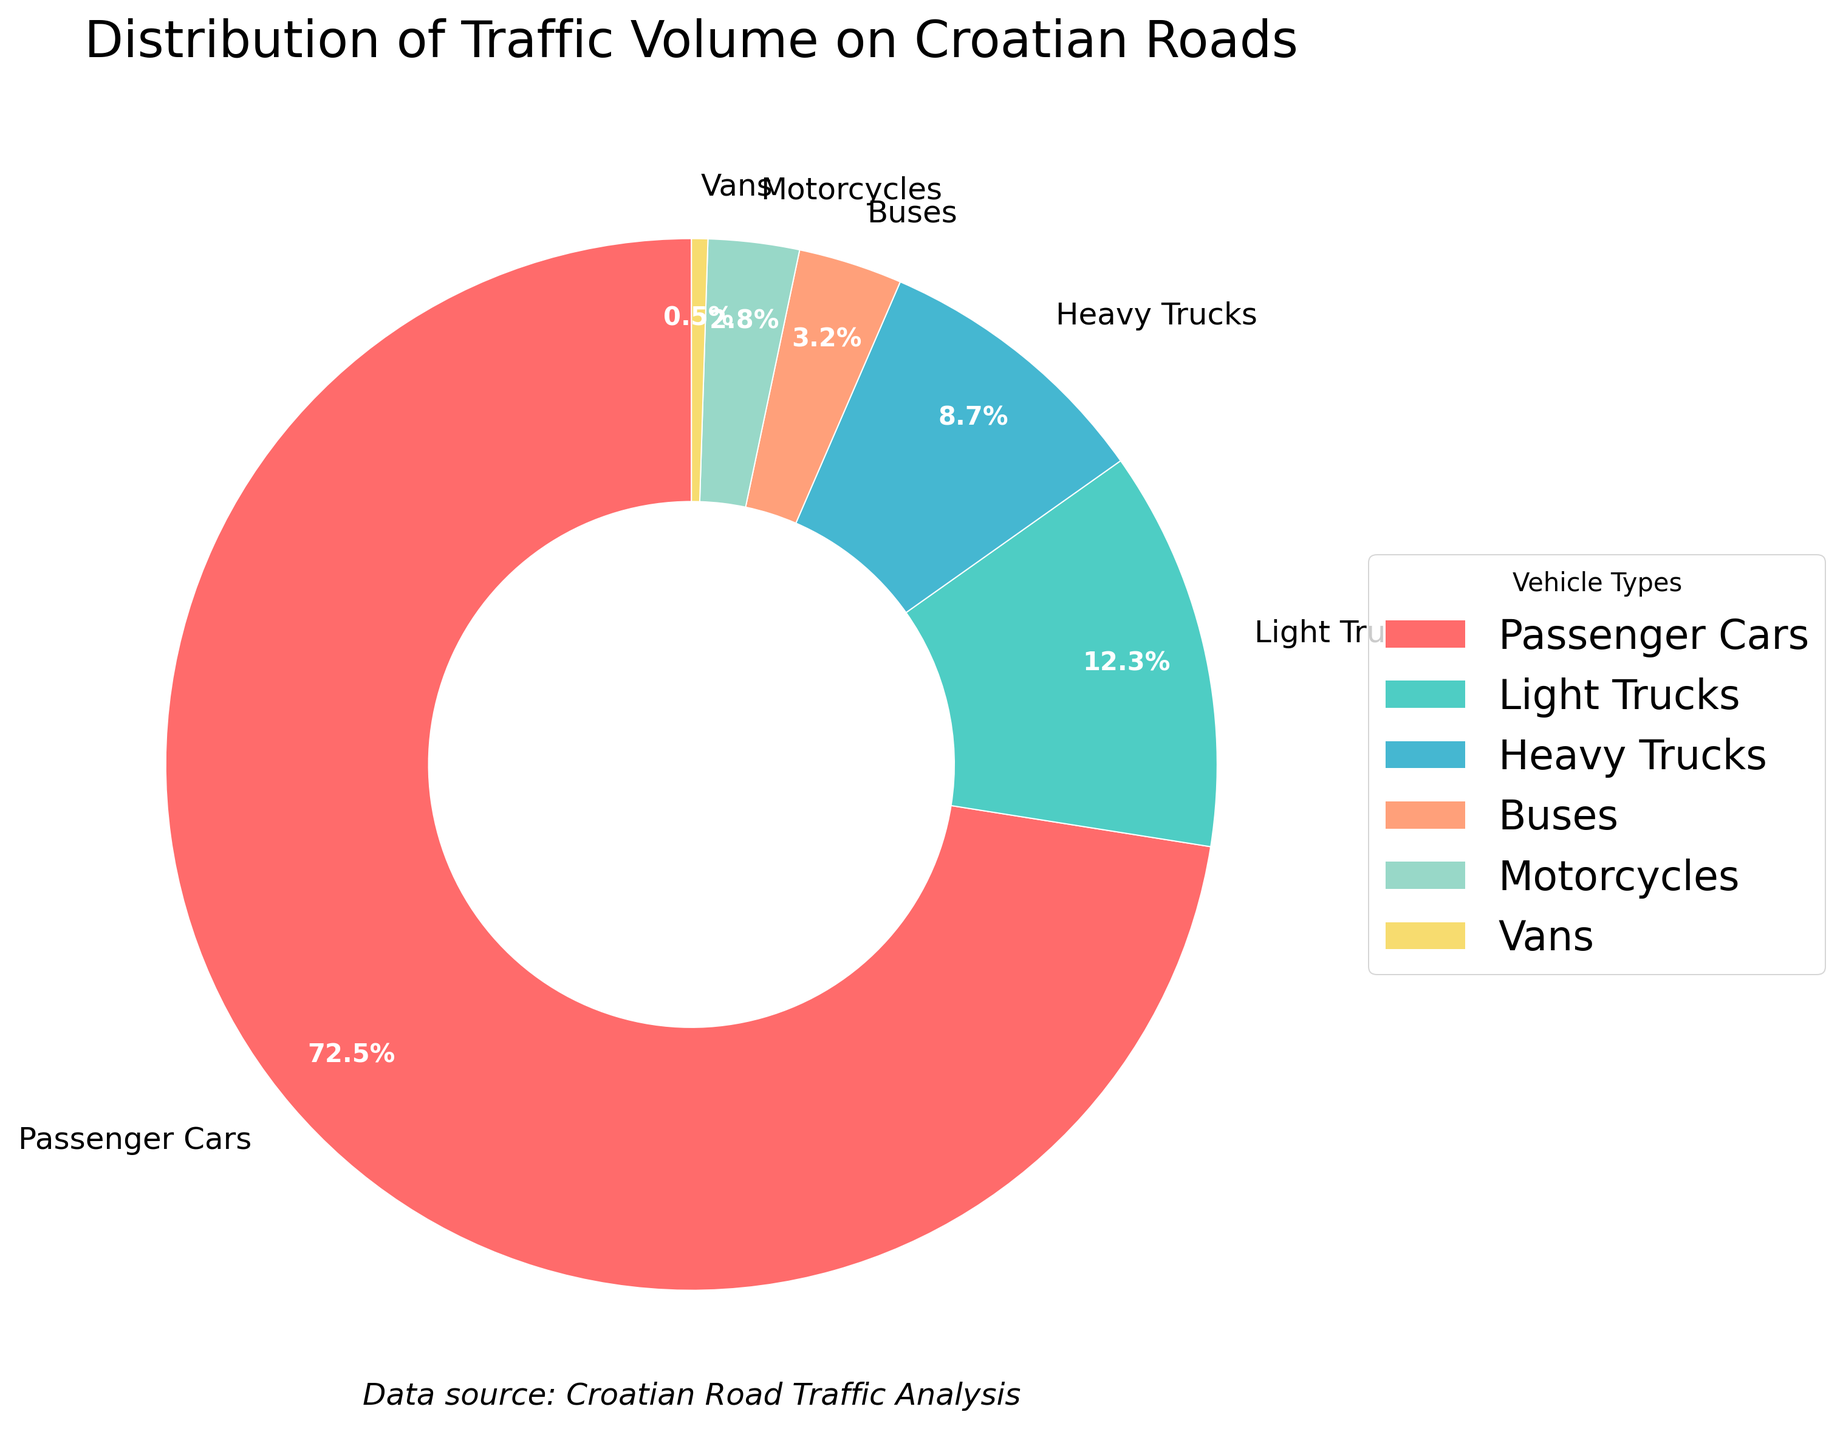What percentage of the traffic volume do trucks (both light and heavy) account for? To determine the total traffic volume percentage for all trucks, add the percentage for light trucks and heavy trucks: 12.3% + 8.7% = 21%
Answer: 21% Which vehicle type has the smallest share of traffic volume? Referring to the figure, the percentage of each vehicle type shows that vans have the smallest share at 0.5%
Answer: Vans How does the traffic volume share of motorcycles compare to that of buses? The chart indicates that motorcycles account for 2.8% of the traffic volume, whereas buses account for 3.2%. Therefore, buses have a slightly higher share.
Answer: Buses have a higher share What's the difference in traffic volume percentage between passenger cars and all forms of trucks? Passenger cars account for 72.5%. The combined share for light and heavy trucks is 21%. So, the difference is 72.5% - 21% = 51.5%
Answer: 51.5% If we combine the traffic volumes of passenger cars, buses, and motorcycles, what’s the total percentage? Add the percentages for passenger cars (72.5%), buses (3.2%), and motorcycles (2.8%): 72.5% + 3.2% + 2.8% = 78.5%
Answer: 78.5% Which vehicle type is depicted in green, based on the color usage in the pie chart? The figure uses different colors for each vehicle type. Green in this context is associated with light trucks.
Answer: Light Trucks Are there more light trucks or heavy trucks in the traffic volume? The chart indicates that light trucks account for 12.3% of the traffic volume, whereas heavy trucks account for 8.7%. So, there are more light trucks.
Answer: Light Trucks What is the combined traffic volume percentage for vehicles other than passenger cars? By summing the percentages for light trucks (12.3%), heavy trucks (8.7%), buses (3.2%), motorcycles (2.8%), and vans (0.5%), we get 27.5%.
Answer: 27.5% Which is greater, the traffic volume for buses or the combined traffic volume for motorcycles and vans? Buses account for 3.2% of the traffic volume. The combined volume for motorcycles (2.8%) and vans (0.5%) is 3.3%. Hence, the combined volume for motorcycles and vans is greater.
Answer: Combined volume for motorcycles and vans 